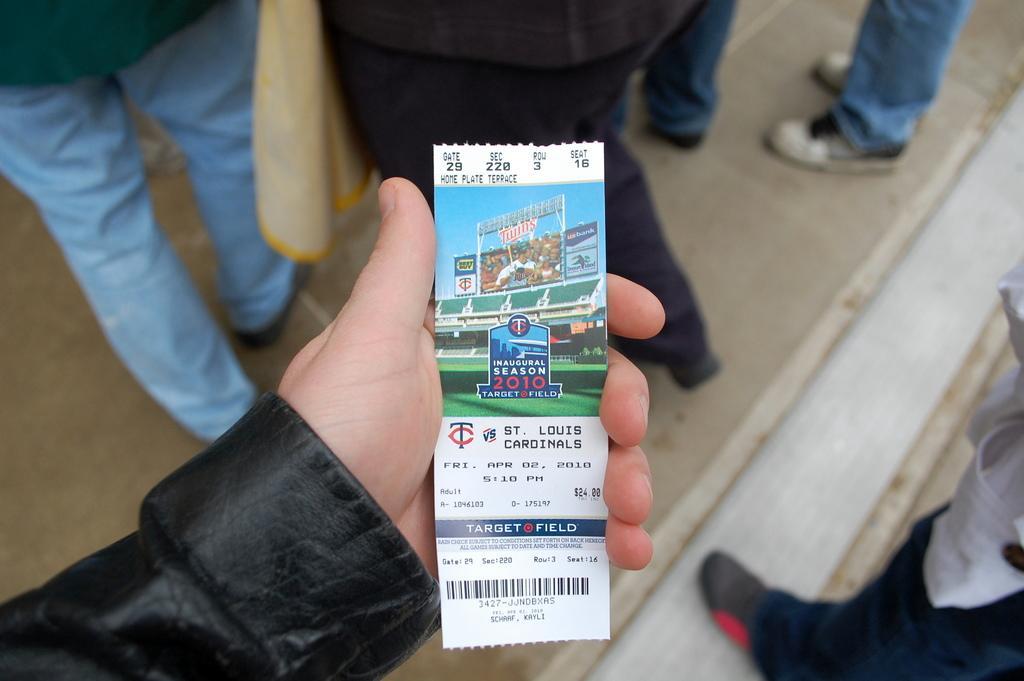Describe this image in one or two sentences. In this picture I can see a paper in a person's hand. On the paper I can see picture of a stadium and some names printed on it. In the background I can see group of people are standing on the ground. 